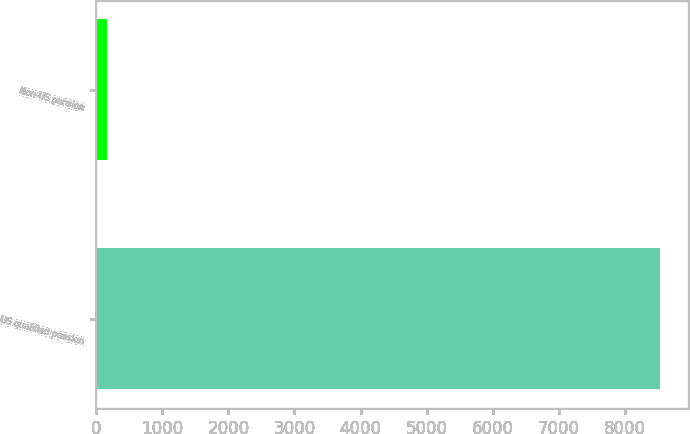Convert chart. <chart><loc_0><loc_0><loc_500><loc_500><bar_chart><fcel>US qualified pension<fcel>Non-US pension<nl><fcel>8540<fcel>162<nl></chart> 